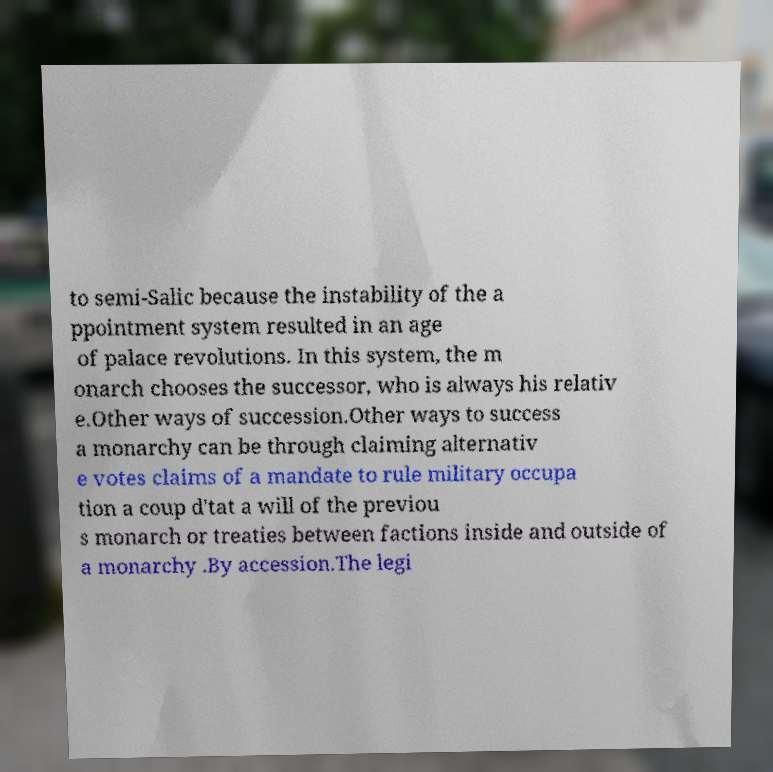What messages or text are displayed in this image? I need them in a readable, typed format. to semi-Salic because the instability of the a ppointment system resulted in an age of palace revolutions. In this system, the m onarch chooses the successor, who is always his relativ e.Other ways of succession.Other ways to success a monarchy can be through claiming alternativ e votes claims of a mandate to rule military occupa tion a coup d'tat a will of the previou s monarch or treaties between factions inside and outside of a monarchy .By accession.The legi 